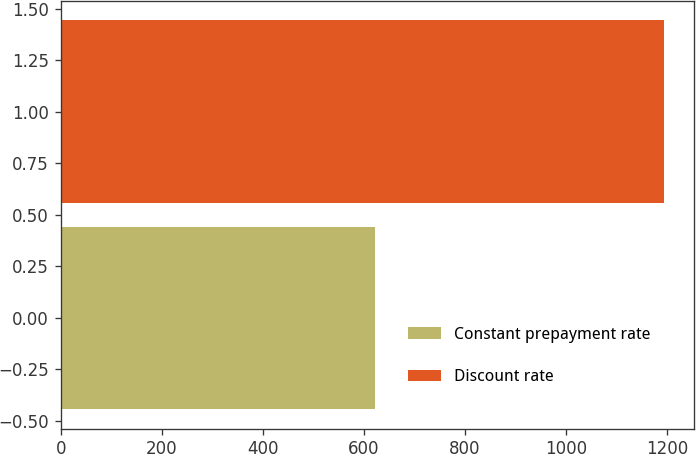<chart> <loc_0><loc_0><loc_500><loc_500><bar_chart><fcel>Constant prepayment rate<fcel>Discount rate<nl><fcel>622<fcel>1194<nl></chart> 